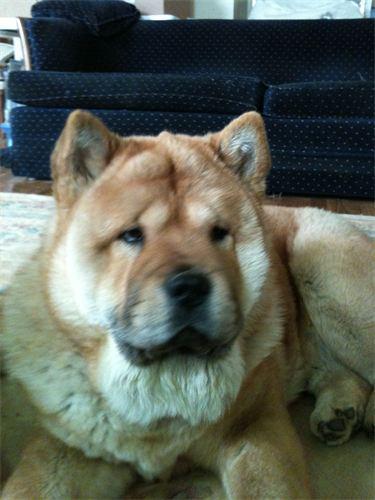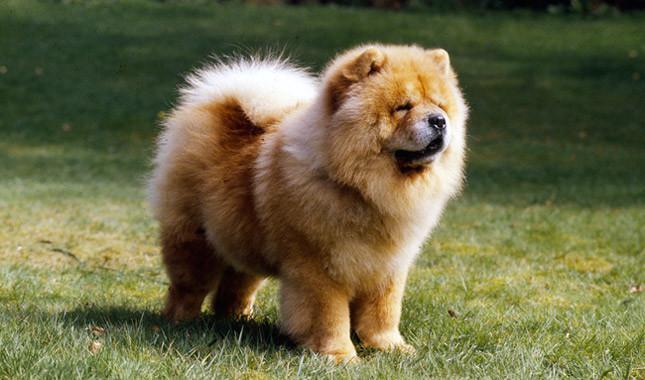The first image is the image on the left, the second image is the image on the right. For the images shown, is this caption "Each image contains one dog, and the dog on the right is standing, while the dog on the left is reclining." true? Answer yes or no. Yes. The first image is the image on the left, the second image is the image on the right. Analyze the images presented: Is the assertion "The dog in the image on the right is standing on all fours." valid? Answer yes or no. Yes. 